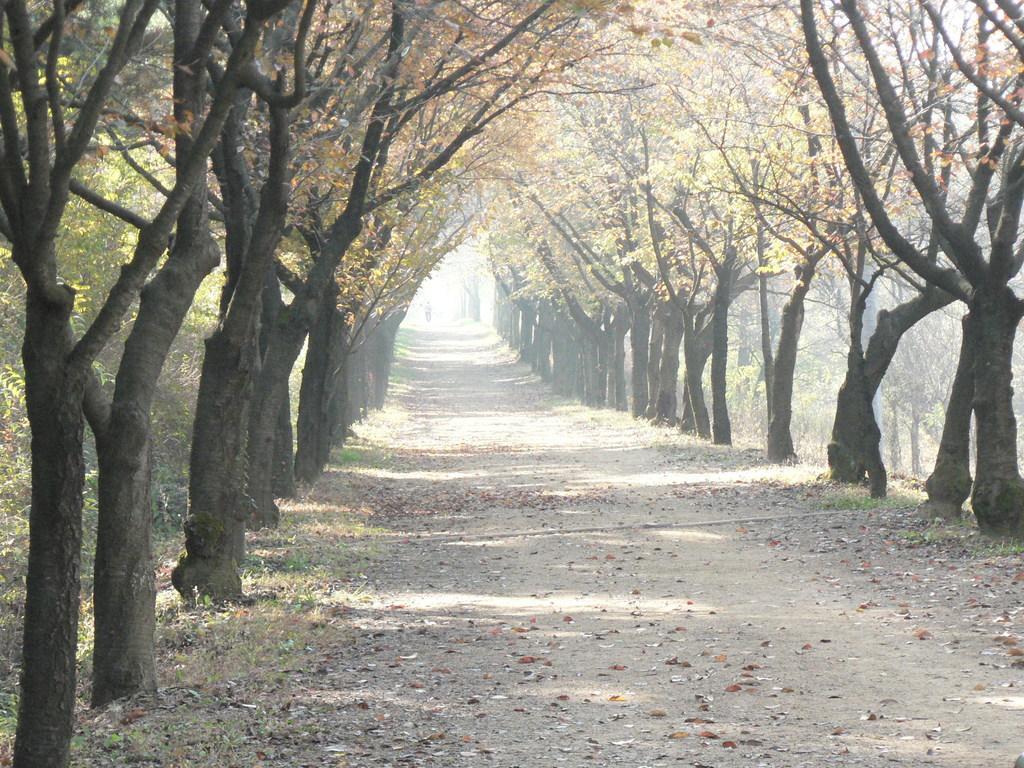Can you describe this image briefly? In this image we can see the road, we can see grass, dry leaves and trees on the either side of the image. 